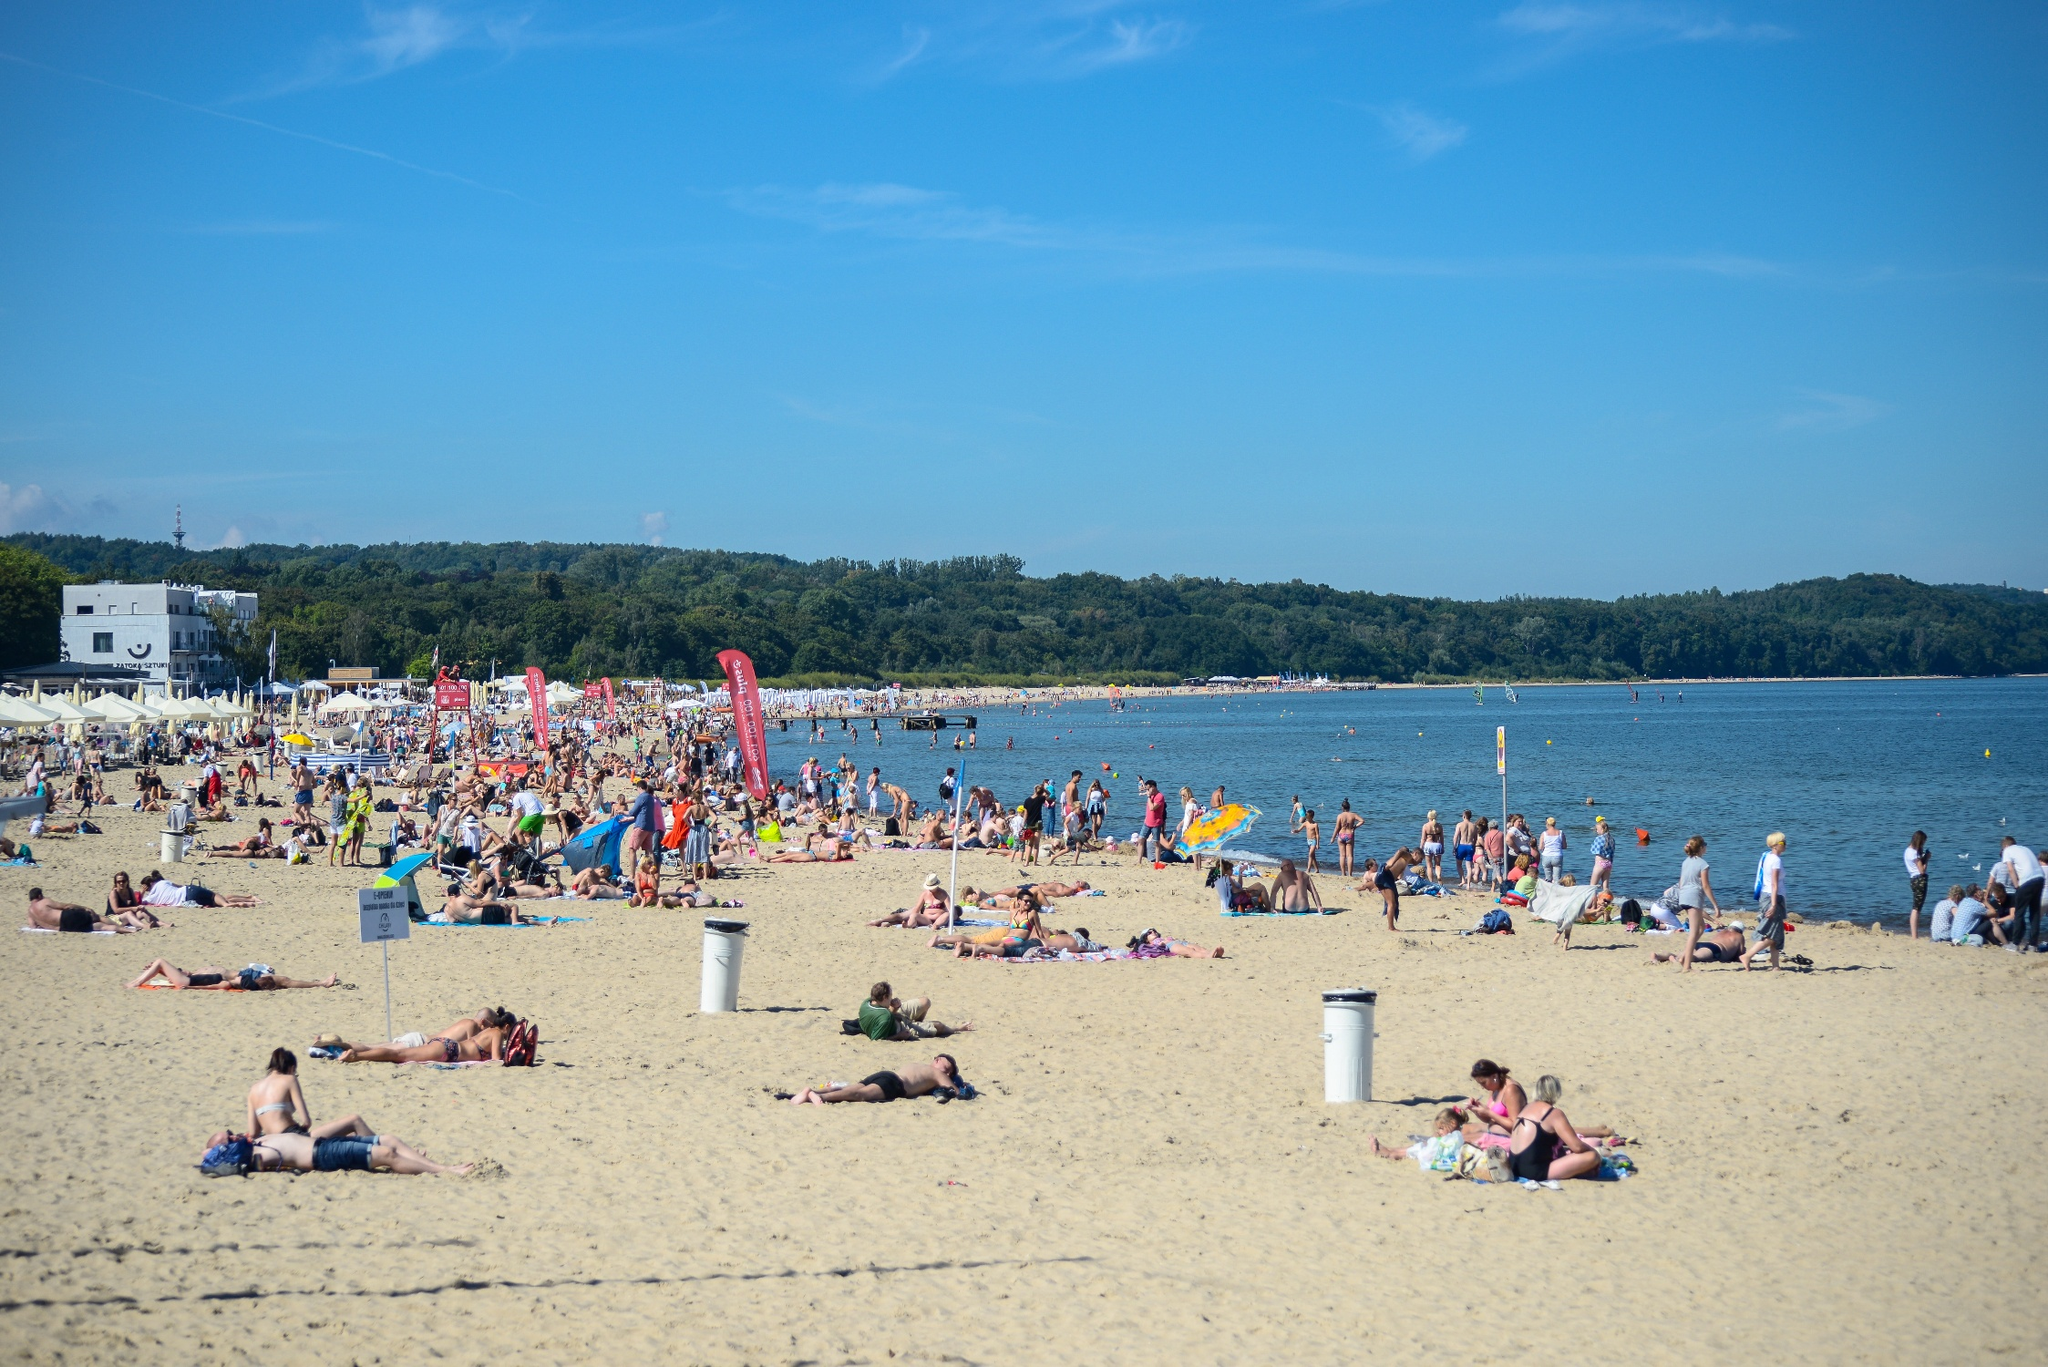What do you see happening in this image? The image illustrates a vibrant and busy beach setting on a day under the clear blue sky. The sandy shore teems with life as people indulge in various beach activities—there are groups sunbathing on colorful towels, some playing beach games, while others walk along the water's edge, perhaps enjoying the coolness of the waves lapping at their feet. Children can be seen building sandcastles, a common joyous pursuit on such sunny days. The background reveals a seaside promenade with buildings that signal a proximity to a town or city. The density of beach umbrellas and individuals suggest it's likely a weekend or a holiday when people flock to the seaside to relax and enjoy the outdoors. The combination of natural beauty and human leisure creates a scene that is both dynamic and serene, encouraging viewers to imagine the sounds of laughter and waves that might be filling the air. 